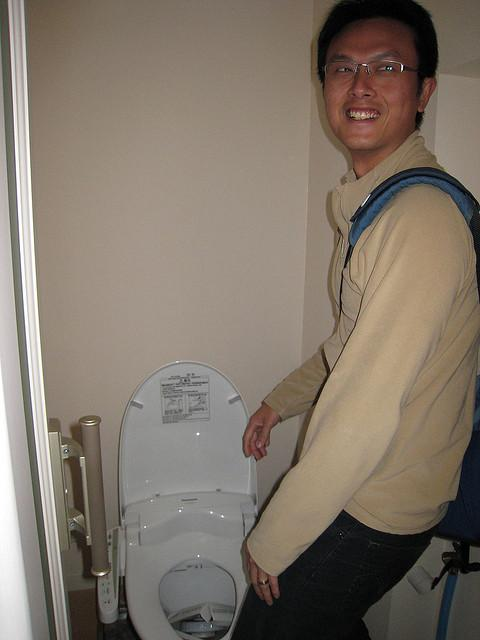What is the man ready to do next? Please explain your reasoning. flush. The man is standing next to a toilet so we can assume he's done what he needed to do and will now purge the system. 